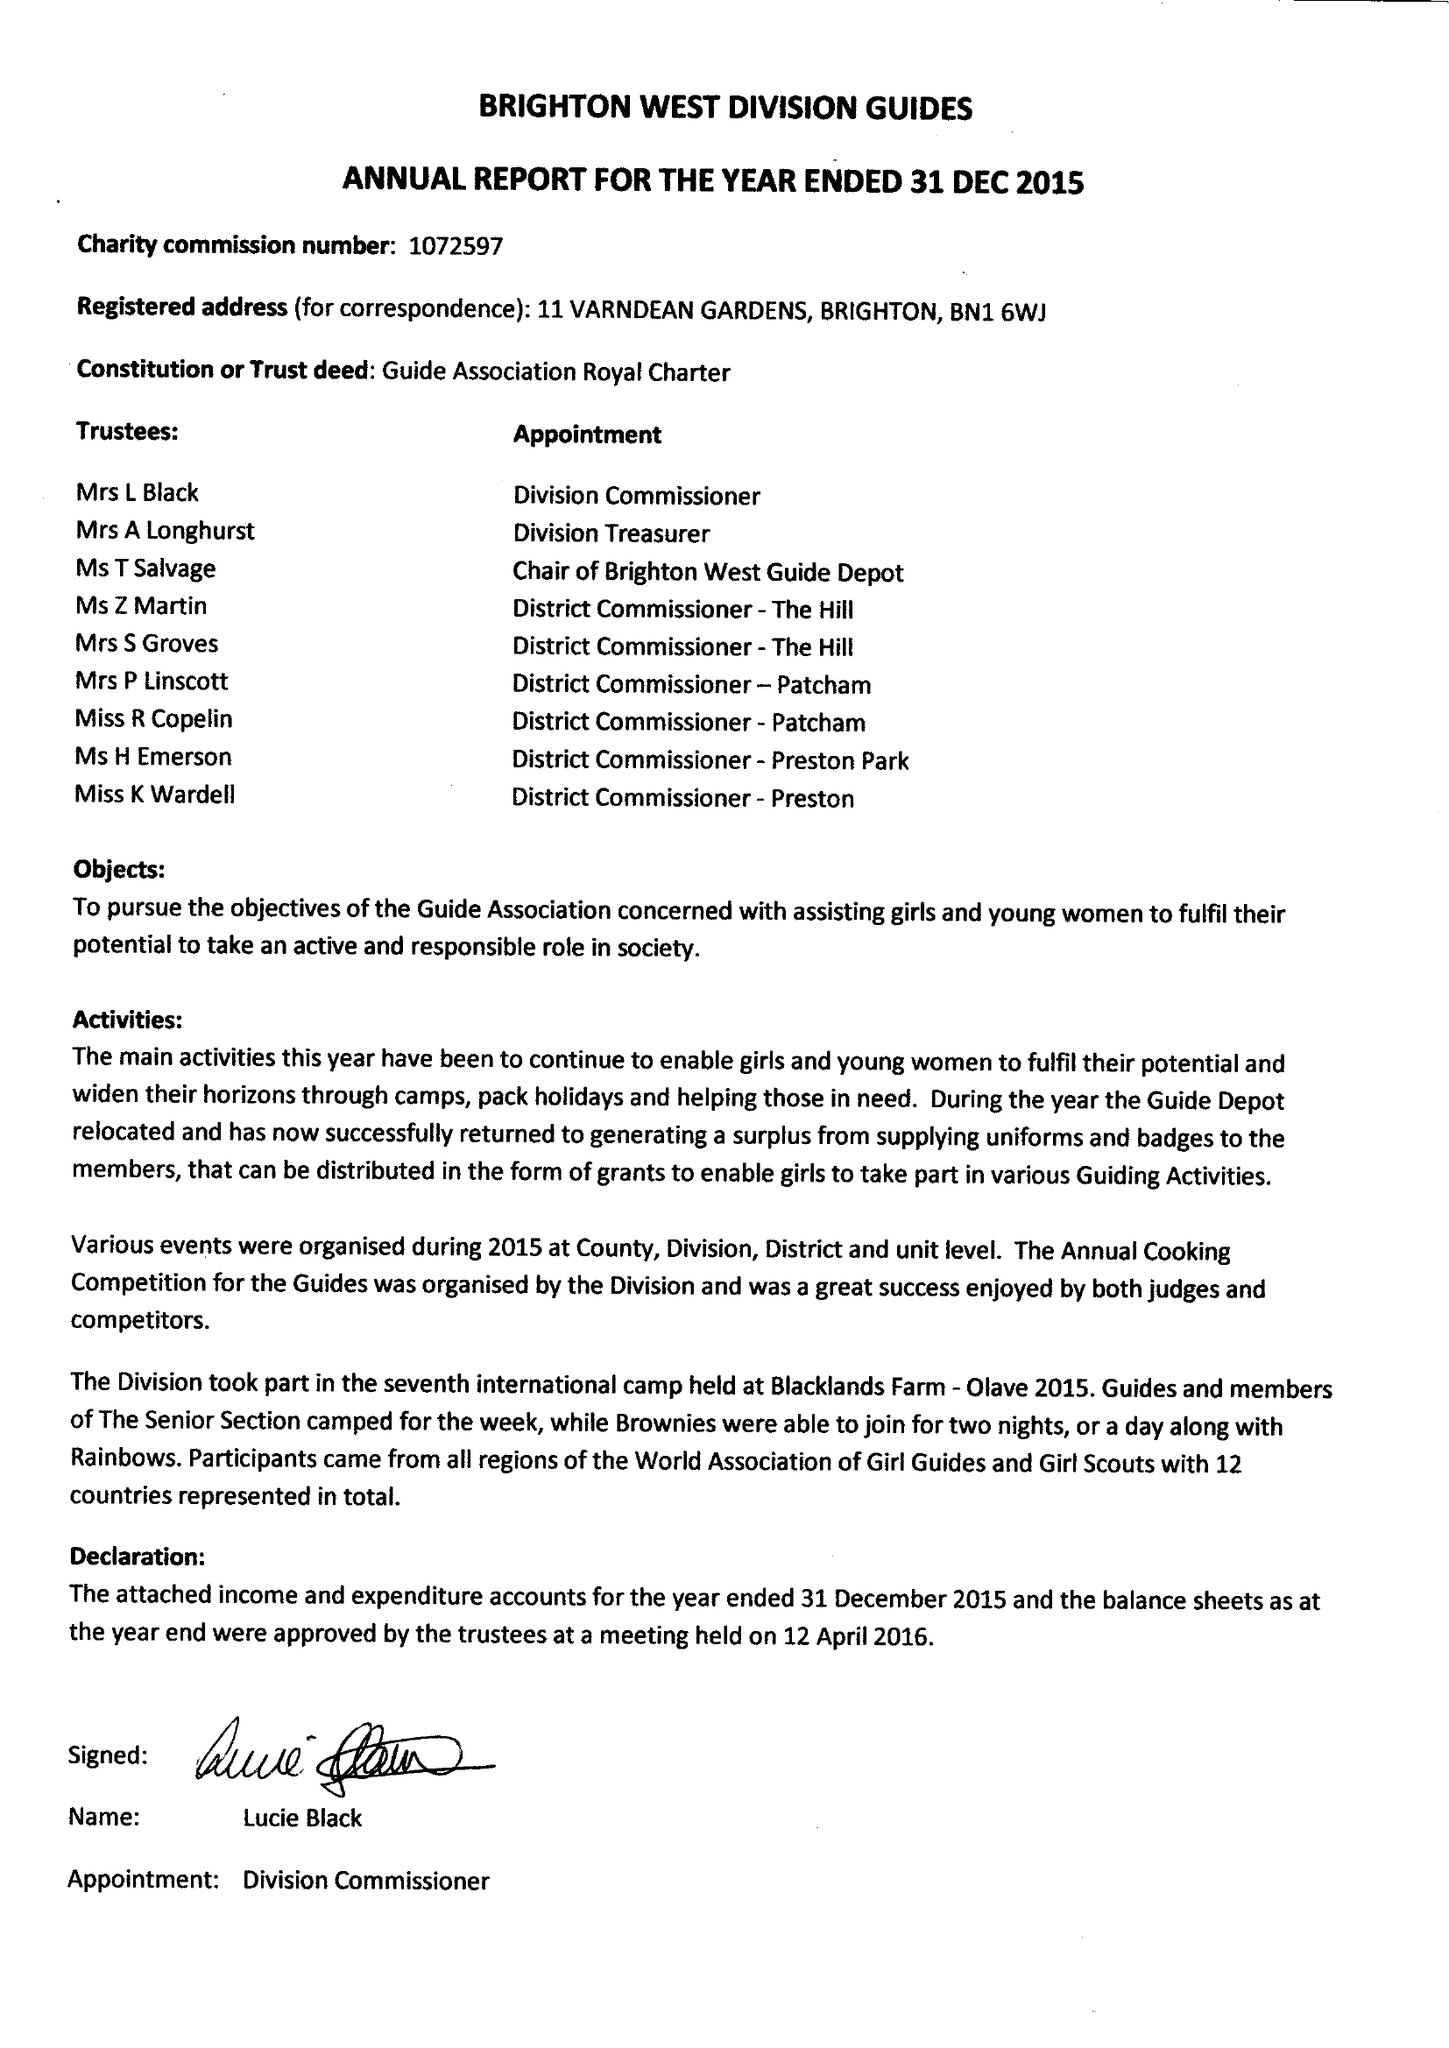What is the value for the address__postcode?
Answer the question using a single word or phrase. BN1 6WJ 